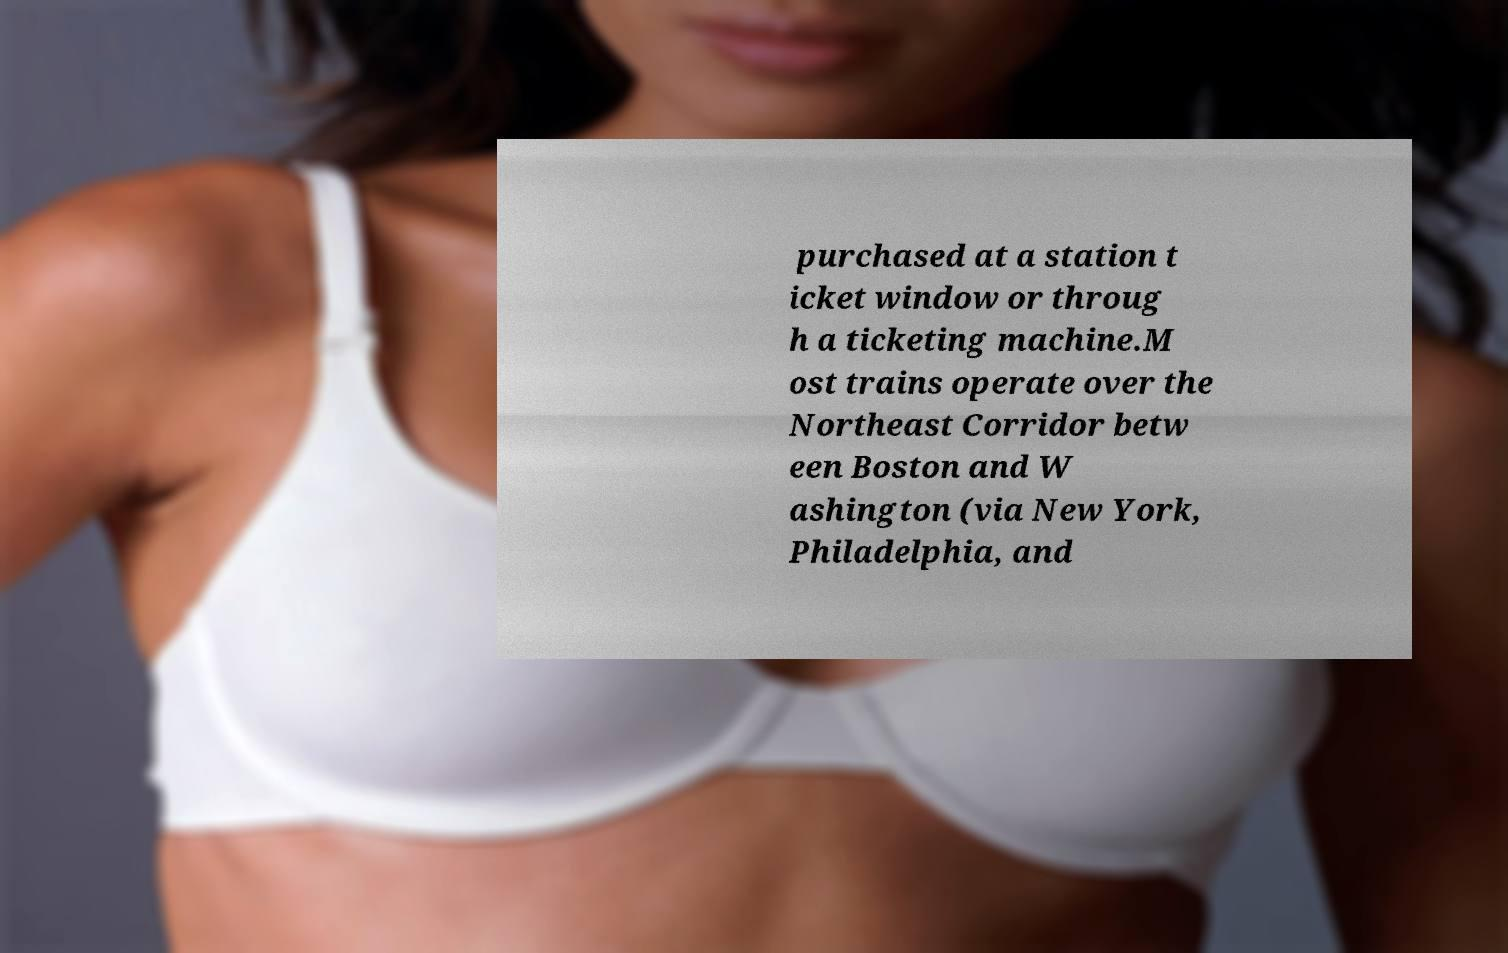For documentation purposes, I need the text within this image transcribed. Could you provide that? purchased at a station t icket window or throug h a ticketing machine.M ost trains operate over the Northeast Corridor betw een Boston and W ashington (via New York, Philadelphia, and 